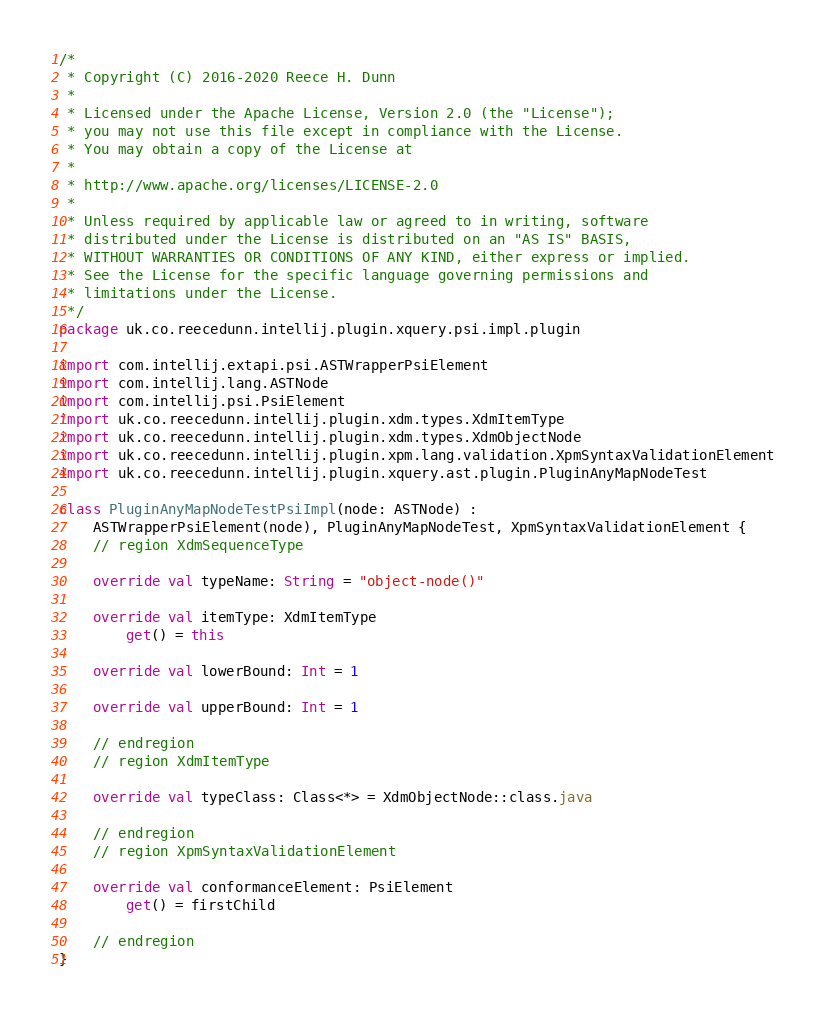<code> <loc_0><loc_0><loc_500><loc_500><_Kotlin_>/*
 * Copyright (C) 2016-2020 Reece H. Dunn
 *
 * Licensed under the Apache License, Version 2.0 (the "License");
 * you may not use this file except in compliance with the License.
 * You may obtain a copy of the License at
 *
 * http://www.apache.org/licenses/LICENSE-2.0
 *
 * Unless required by applicable law or agreed to in writing, software
 * distributed under the License is distributed on an "AS IS" BASIS,
 * WITHOUT WARRANTIES OR CONDITIONS OF ANY KIND, either express or implied.
 * See the License for the specific language governing permissions and
 * limitations under the License.
 */
package uk.co.reecedunn.intellij.plugin.xquery.psi.impl.plugin

import com.intellij.extapi.psi.ASTWrapperPsiElement
import com.intellij.lang.ASTNode
import com.intellij.psi.PsiElement
import uk.co.reecedunn.intellij.plugin.xdm.types.XdmItemType
import uk.co.reecedunn.intellij.plugin.xdm.types.XdmObjectNode
import uk.co.reecedunn.intellij.plugin.xpm.lang.validation.XpmSyntaxValidationElement
import uk.co.reecedunn.intellij.plugin.xquery.ast.plugin.PluginAnyMapNodeTest

class PluginAnyMapNodeTestPsiImpl(node: ASTNode) :
    ASTWrapperPsiElement(node), PluginAnyMapNodeTest, XpmSyntaxValidationElement {
    // region XdmSequenceType

    override val typeName: String = "object-node()"

    override val itemType: XdmItemType
        get() = this

    override val lowerBound: Int = 1

    override val upperBound: Int = 1

    // endregion
    // region XdmItemType

    override val typeClass: Class<*> = XdmObjectNode::class.java

    // endregion
    // region XpmSyntaxValidationElement

    override val conformanceElement: PsiElement
        get() = firstChild

    // endregion
}
</code> 